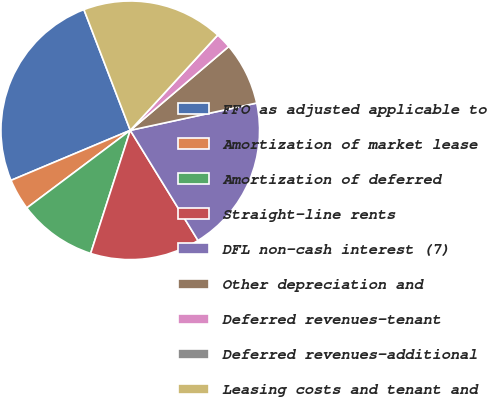Convert chart to OTSL. <chart><loc_0><loc_0><loc_500><loc_500><pie_chart><fcel>FFO as adjusted applicable to<fcel>Amortization of market lease<fcel>Amortization of deferred<fcel>Straight-line rents<fcel>DFL non-cash interest (7)<fcel>Other depreciation and<fcel>Deferred revenues-tenant<fcel>Deferred revenues-additional<fcel>Leasing costs and tenant and<nl><fcel>25.49%<fcel>3.92%<fcel>9.8%<fcel>13.73%<fcel>19.61%<fcel>7.84%<fcel>1.96%<fcel>0.0%<fcel>17.65%<nl></chart> 